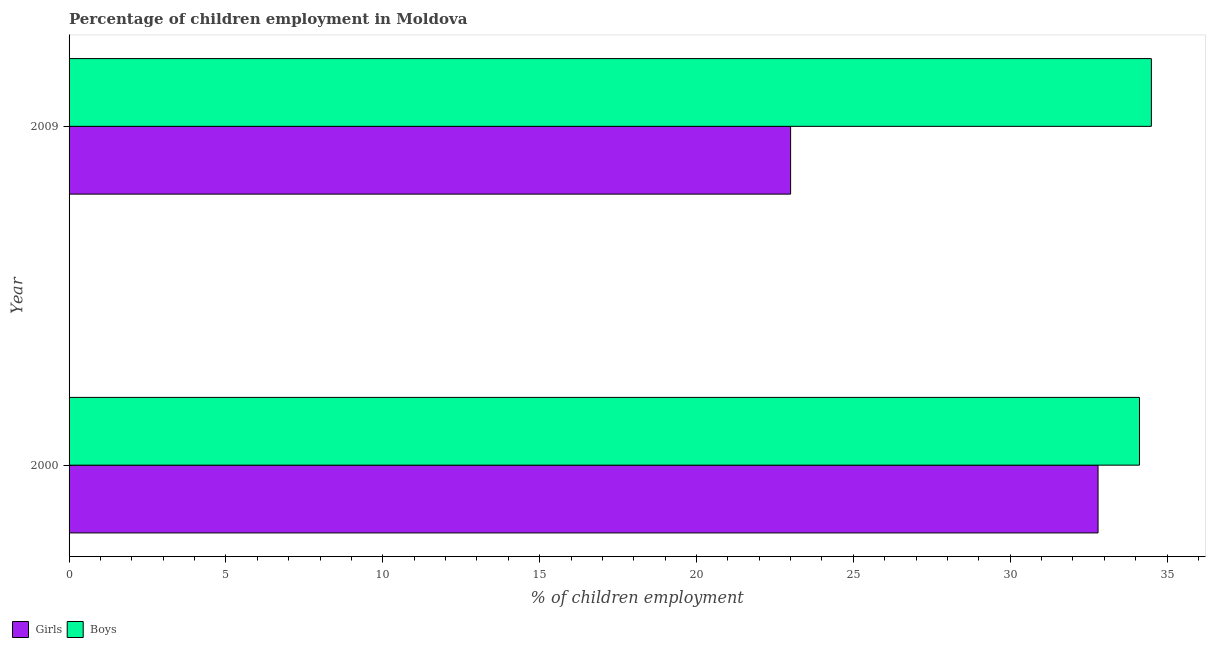How many different coloured bars are there?
Make the answer very short. 2. How many groups of bars are there?
Ensure brevity in your answer.  2. Are the number of bars on each tick of the Y-axis equal?
Your answer should be very brief. Yes. How many bars are there on the 2nd tick from the bottom?
Keep it short and to the point. 2. In how many cases, is the number of bars for a given year not equal to the number of legend labels?
Provide a short and direct response. 0. What is the percentage of employed girls in 2000?
Make the answer very short. 32.8. Across all years, what is the maximum percentage of employed boys?
Offer a terse response. 34.5. Across all years, what is the minimum percentage of employed boys?
Your answer should be very brief. 34.12. What is the total percentage of employed boys in the graph?
Keep it short and to the point. 68.62. What is the difference between the percentage of employed girls in 2000 and that in 2009?
Offer a terse response. 9.8. What is the difference between the percentage of employed boys in 2000 and the percentage of employed girls in 2009?
Ensure brevity in your answer.  11.12. What is the average percentage of employed girls per year?
Offer a very short reply. 27.9. In the year 2000, what is the difference between the percentage of employed girls and percentage of employed boys?
Ensure brevity in your answer.  -1.32. In how many years, is the percentage of employed boys greater than 14 %?
Keep it short and to the point. 2. What is the ratio of the percentage of employed girls in 2000 to that in 2009?
Keep it short and to the point. 1.43. Is the percentage of employed girls in 2000 less than that in 2009?
Provide a succinct answer. No. In how many years, is the percentage of employed boys greater than the average percentage of employed boys taken over all years?
Provide a short and direct response. 1. What does the 2nd bar from the top in 2000 represents?
Provide a succinct answer. Girls. What does the 2nd bar from the bottom in 2009 represents?
Give a very brief answer. Boys. How many years are there in the graph?
Make the answer very short. 2. What is the difference between two consecutive major ticks on the X-axis?
Your answer should be compact. 5. Are the values on the major ticks of X-axis written in scientific E-notation?
Your answer should be very brief. No. Does the graph contain any zero values?
Provide a succinct answer. No. Does the graph contain grids?
Offer a terse response. No. What is the title of the graph?
Your answer should be compact. Percentage of children employment in Moldova. What is the label or title of the X-axis?
Provide a short and direct response. % of children employment. What is the % of children employment of Girls in 2000?
Provide a short and direct response. 32.8. What is the % of children employment in Boys in 2000?
Keep it short and to the point. 34.12. What is the % of children employment in Girls in 2009?
Provide a short and direct response. 23. What is the % of children employment in Boys in 2009?
Make the answer very short. 34.5. Across all years, what is the maximum % of children employment of Girls?
Your answer should be compact. 32.8. Across all years, what is the maximum % of children employment in Boys?
Make the answer very short. 34.5. Across all years, what is the minimum % of children employment of Girls?
Offer a very short reply. 23. Across all years, what is the minimum % of children employment in Boys?
Provide a short and direct response. 34.12. What is the total % of children employment in Girls in the graph?
Give a very brief answer. 55.8. What is the total % of children employment in Boys in the graph?
Give a very brief answer. 68.62. What is the difference between the % of children employment in Girls in 2000 and that in 2009?
Make the answer very short. 9.8. What is the difference between the % of children employment of Boys in 2000 and that in 2009?
Provide a short and direct response. -0.38. What is the difference between the % of children employment of Girls in 2000 and the % of children employment of Boys in 2009?
Offer a terse response. -1.7. What is the average % of children employment in Girls per year?
Offer a terse response. 27.9. What is the average % of children employment of Boys per year?
Make the answer very short. 34.31. In the year 2000, what is the difference between the % of children employment of Girls and % of children employment of Boys?
Your response must be concise. -1.32. In the year 2009, what is the difference between the % of children employment in Girls and % of children employment in Boys?
Offer a terse response. -11.5. What is the ratio of the % of children employment in Girls in 2000 to that in 2009?
Your answer should be very brief. 1.43. What is the ratio of the % of children employment of Boys in 2000 to that in 2009?
Your response must be concise. 0.99. What is the difference between the highest and the second highest % of children employment in Girls?
Offer a terse response. 9.8. What is the difference between the highest and the second highest % of children employment in Boys?
Provide a succinct answer. 0.38. What is the difference between the highest and the lowest % of children employment in Girls?
Your response must be concise. 9.8. What is the difference between the highest and the lowest % of children employment of Boys?
Offer a terse response. 0.38. 